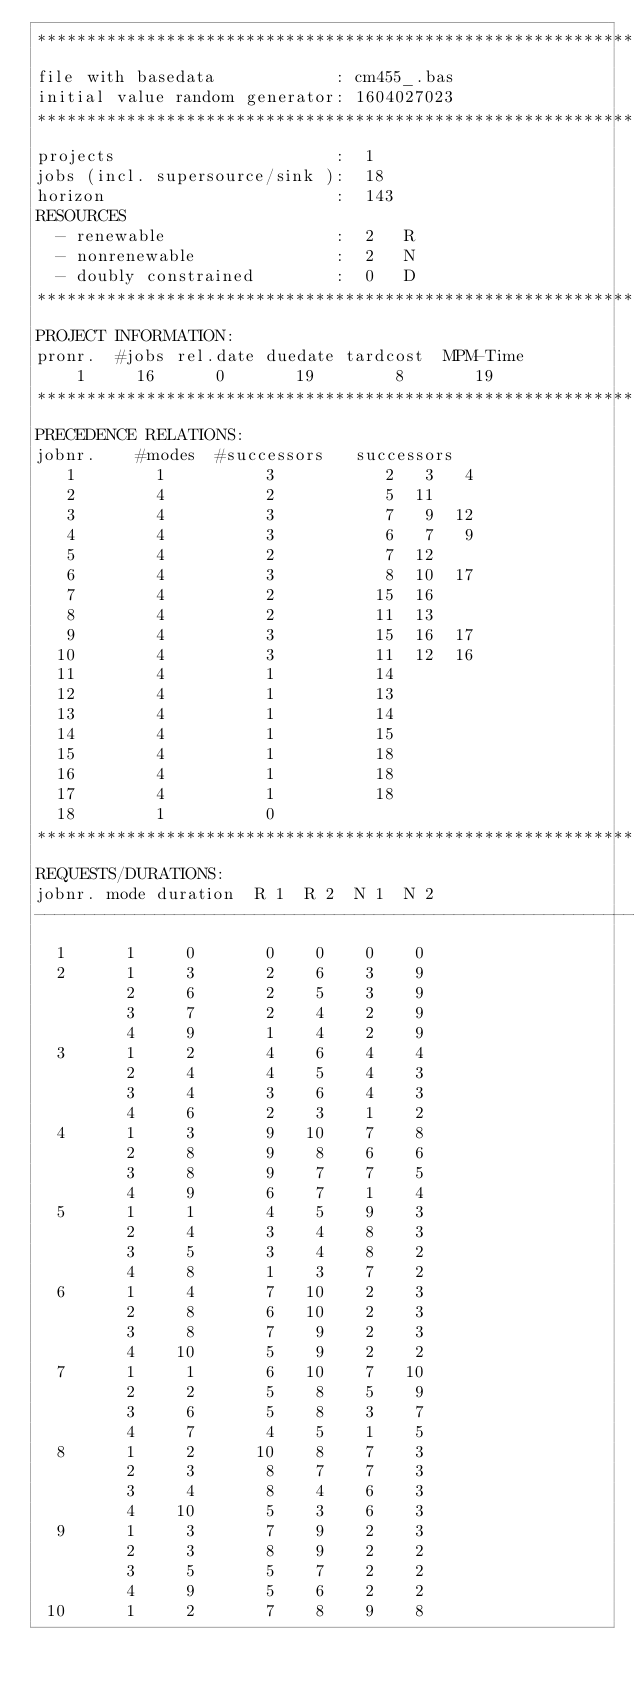Convert code to text. <code><loc_0><loc_0><loc_500><loc_500><_ObjectiveC_>************************************************************************
file with basedata            : cm455_.bas
initial value random generator: 1604027023
************************************************************************
projects                      :  1
jobs (incl. supersource/sink ):  18
horizon                       :  143
RESOURCES
  - renewable                 :  2   R
  - nonrenewable              :  2   N
  - doubly constrained        :  0   D
************************************************************************
PROJECT INFORMATION:
pronr.  #jobs rel.date duedate tardcost  MPM-Time
    1     16      0       19        8       19
************************************************************************
PRECEDENCE RELATIONS:
jobnr.    #modes  #successors   successors
   1        1          3           2   3   4
   2        4          2           5  11
   3        4          3           7   9  12
   4        4          3           6   7   9
   5        4          2           7  12
   6        4          3           8  10  17
   7        4          2          15  16
   8        4          2          11  13
   9        4          3          15  16  17
  10        4          3          11  12  16
  11        4          1          14
  12        4          1          13
  13        4          1          14
  14        4          1          15
  15        4          1          18
  16        4          1          18
  17        4          1          18
  18        1          0        
************************************************************************
REQUESTS/DURATIONS:
jobnr. mode duration  R 1  R 2  N 1  N 2
------------------------------------------------------------------------
  1      1     0       0    0    0    0
  2      1     3       2    6    3    9
         2     6       2    5    3    9
         3     7       2    4    2    9
         4     9       1    4    2    9
  3      1     2       4    6    4    4
         2     4       4    5    4    3
         3     4       3    6    4    3
         4     6       2    3    1    2
  4      1     3       9   10    7    8
         2     8       9    8    6    6
         3     8       9    7    7    5
         4     9       6    7    1    4
  5      1     1       4    5    9    3
         2     4       3    4    8    3
         3     5       3    4    8    2
         4     8       1    3    7    2
  6      1     4       7   10    2    3
         2     8       6   10    2    3
         3     8       7    9    2    3
         4    10       5    9    2    2
  7      1     1       6   10    7   10
         2     2       5    8    5    9
         3     6       5    8    3    7
         4     7       4    5    1    5
  8      1     2      10    8    7    3
         2     3       8    7    7    3
         3     4       8    4    6    3
         4    10       5    3    6    3
  9      1     3       7    9    2    3
         2     3       8    9    2    2
         3     5       5    7    2    2
         4     9       5    6    2    2
 10      1     2       7    8    9    8</code> 